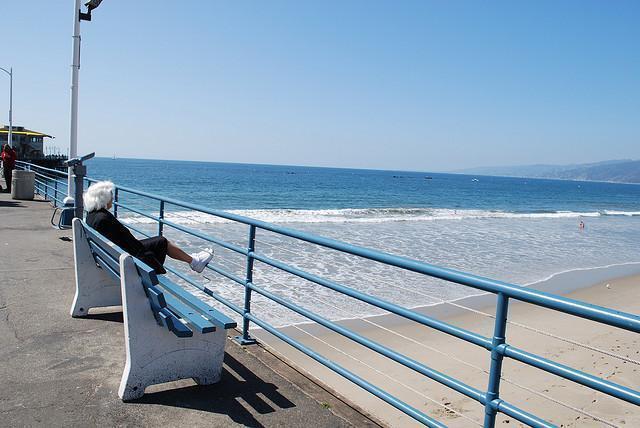What is the name of the structure the bench is sitting on?
Pick the right solution, then justify: 'Answer: answer
Rationale: rationale.'
Options: Ramp, pier, dais, island. Answer: pier.
Rationale: This is a pier that you can walk out on to look at the water. 